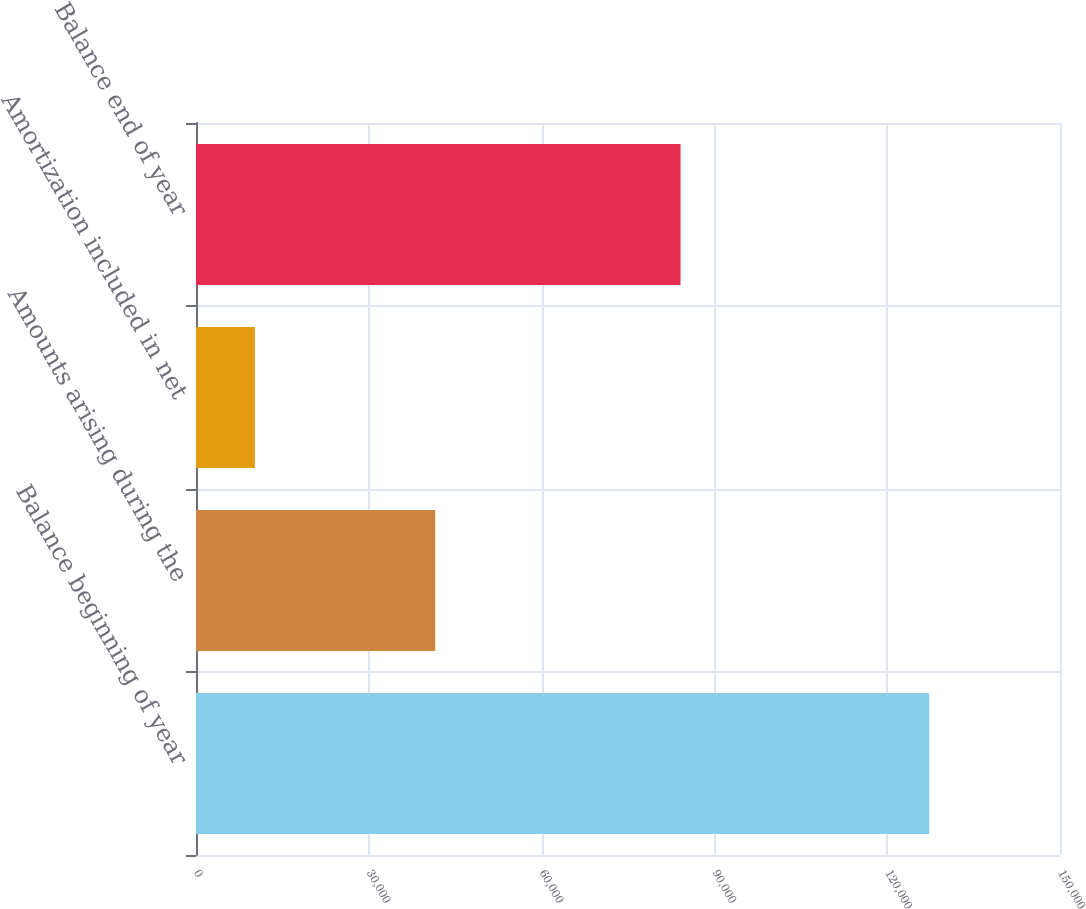Convert chart to OTSL. <chart><loc_0><loc_0><loc_500><loc_500><bar_chart><fcel>Balance beginning of year<fcel>Amounts arising during the<fcel>Amortization included in net<fcel>Balance end of year<nl><fcel>127292<fcel>41532<fcel>10218<fcel>84122<nl></chart> 